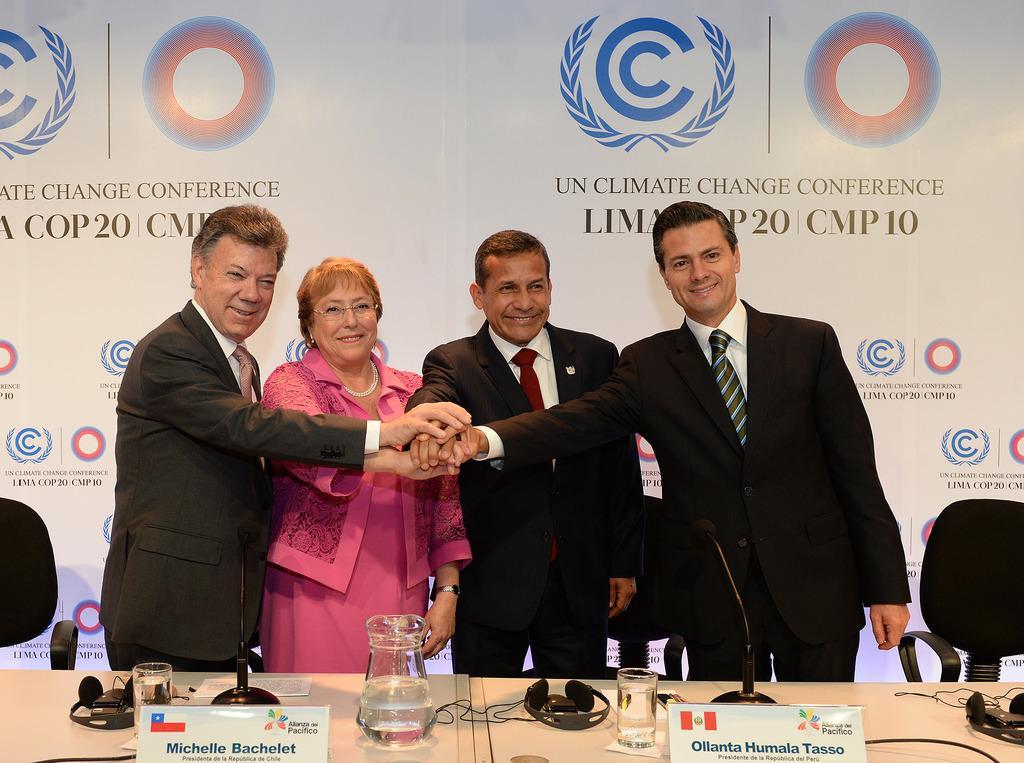In one or two sentences, can you explain what this image depicts? In the picture we can see three men and a woman standing near the table and holding the hands and men are in blazers, ties and shirts and woman is in the pink dress and on the table, we can see a jar with water and some glasses with water and some name boards and headsets and in the background we can see the hoarding with some brand symbols. 